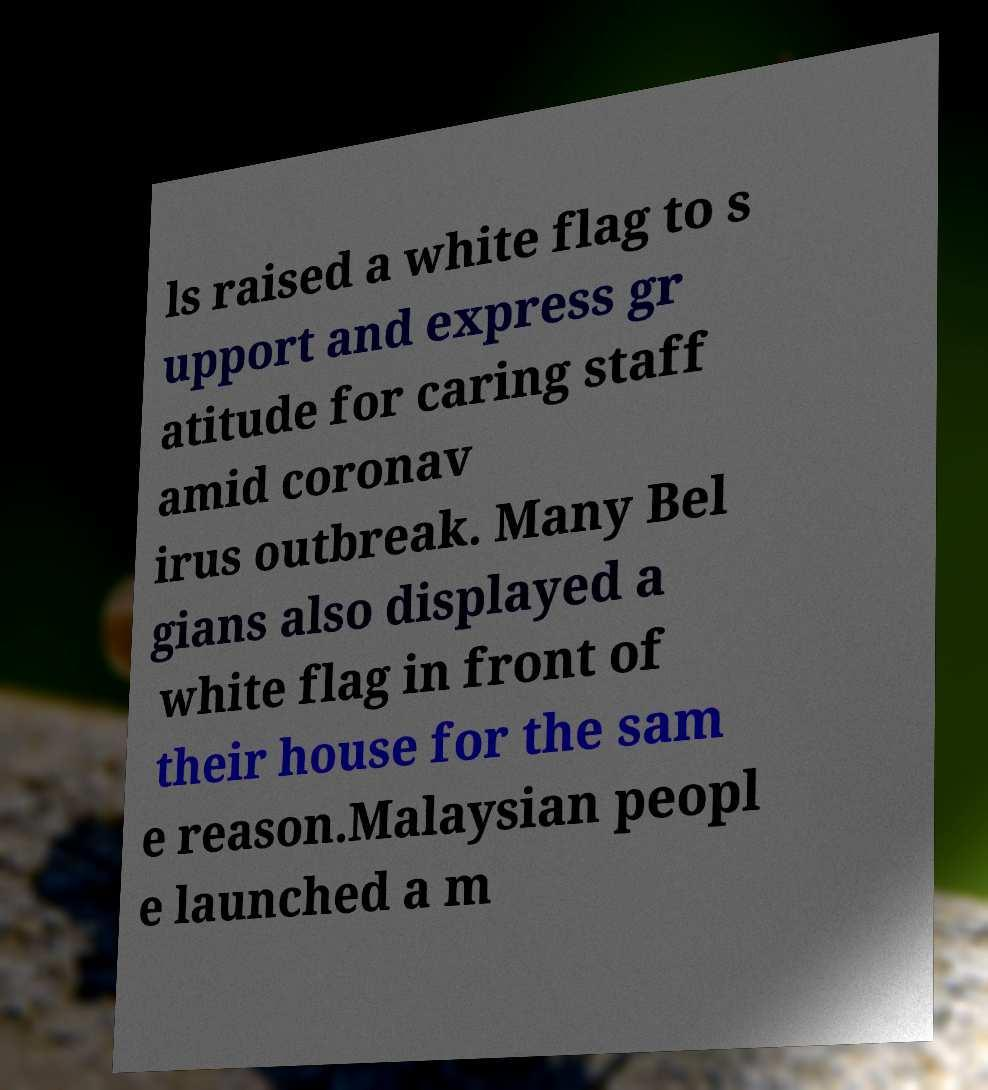Can you accurately transcribe the text from the provided image for me? ls raised a white flag to s upport and express gr atitude for caring staff amid coronav irus outbreak. Many Bel gians also displayed a white flag in front of their house for the sam e reason.Malaysian peopl e launched a m 